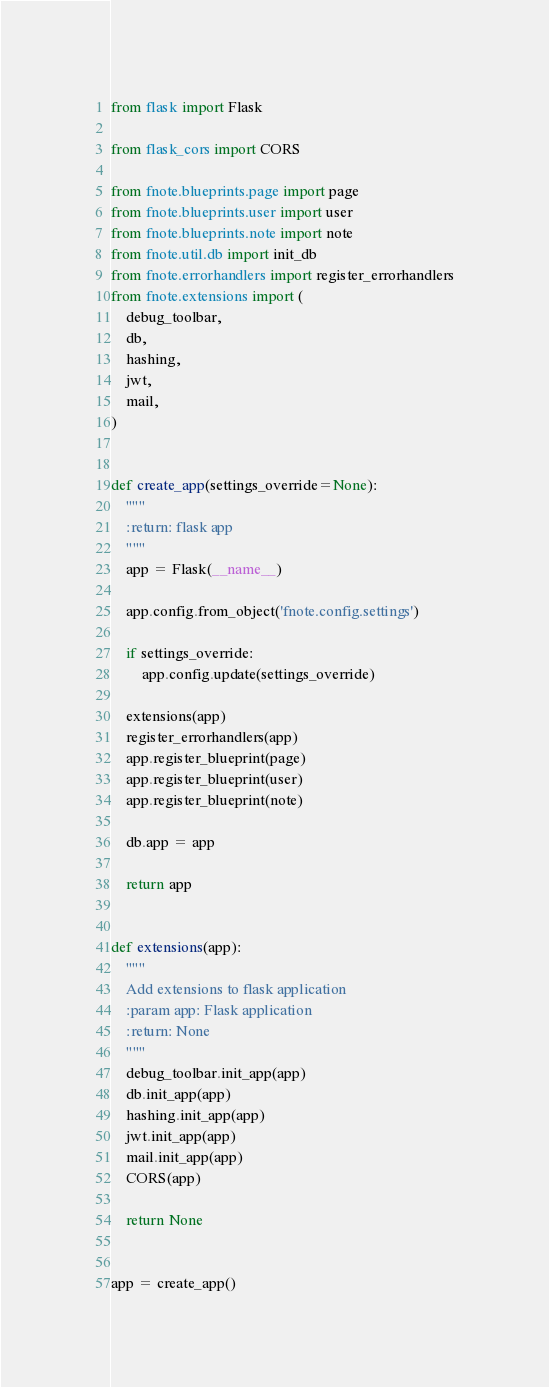<code> <loc_0><loc_0><loc_500><loc_500><_Python_>from flask import Flask

from flask_cors import CORS

from fnote.blueprints.page import page
from fnote.blueprints.user import user
from fnote.blueprints.note import note
from fnote.util.db import init_db
from fnote.errorhandlers import register_errorhandlers
from fnote.extensions import (
    debug_toolbar,
    db,
    hashing,
    jwt,
    mail,
)


def create_app(settings_override=None):
    """
    :return: flask app
    """
    app = Flask(__name__)

    app.config.from_object('fnote.config.settings')

    if settings_override:
        app.config.update(settings_override)

    extensions(app)
    register_errorhandlers(app)
    app.register_blueprint(page)
    app.register_blueprint(user)
    app.register_blueprint(note)

    db.app = app

    return app


def extensions(app):
    """
    Add extensions to flask application
    :param app: Flask application
    :return: None
    """
    debug_toolbar.init_app(app)
    db.init_app(app)
    hashing.init_app(app)
    jwt.init_app(app)
    mail.init_app(app)
    CORS(app)

    return None


app = create_app()
</code> 